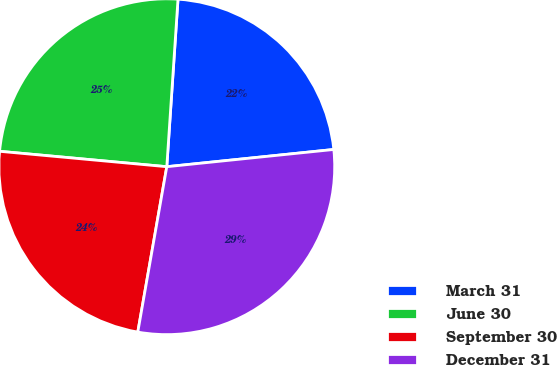<chart> <loc_0><loc_0><loc_500><loc_500><pie_chart><fcel>March 31<fcel>June 30<fcel>September 30<fcel>December 31<nl><fcel>22.3%<fcel>24.6%<fcel>23.7%<fcel>29.4%<nl></chart> 